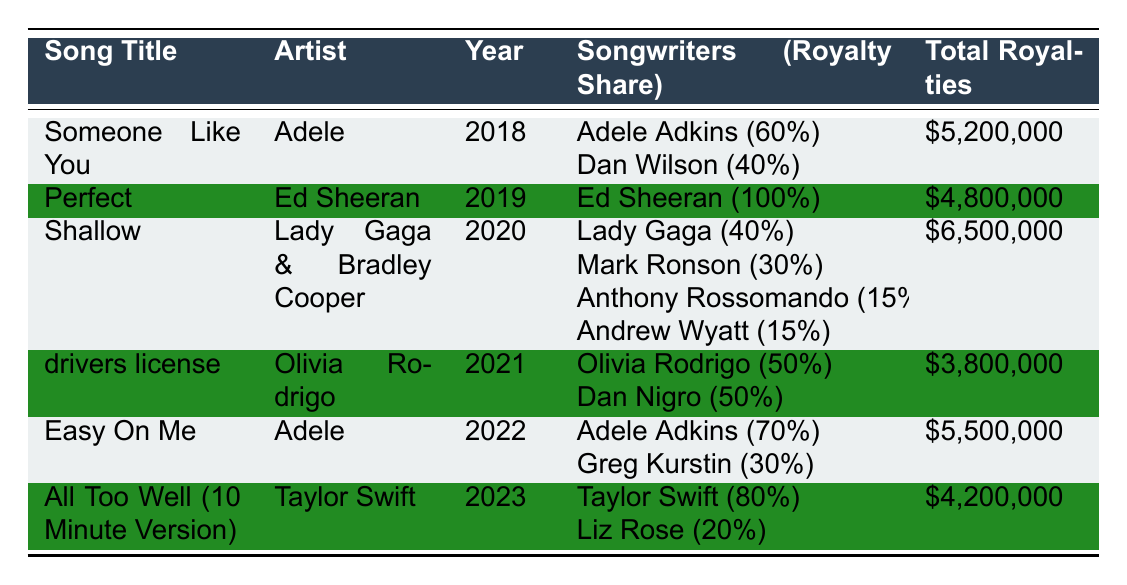What is the total royalty for the song "Shallow"? Referring to the table, the total royalties listed for "Shallow" is $6,500,000.
Answer: $6,500,000 Who are the songwriters for "drivers license"? Looking at the table, the songwriters for "drivers license" are Olivia Rodrigo and Dan Nigro.
Answer: Olivia Rodrigo and Dan Nigro Which artist had the highest total royalties for their song? Comparing the total royalties among all songs, "Shallow" by Lady Gaga & Bradley Cooper has the highest at $6,500,000.
Answer: Lady Gaga & Bradley Cooper How much did Adele earn from her songs combined? To find this, sum the total royalties of both "Someone Like You" ($5,200,000) and "Easy On Me" ($5,500,000): $5,200,000 + $5,500,000 = $10,700,000.
Answer: $10,700,000 Did "Perfect" generate more or less than $5,000,000 in royalties? The total royalties for "Perfect" is $4,800,000, which is less than $5,000,000.
Answer: Less What percentage of royalties did Taylor Swift receive from "All Too Well (10 Minute Version)"? In the table, it states that Taylor Swift received a royalty share of 80% for this song.
Answer: 80% Which year had the lowest total royalties for a chart-topping ballad? The table shows that "drivers license" had the lowest total royalties of $3,800,000 in 2021.
Answer: 2021 If we average the total royalties of all songs listed, what is that value? First, sum all total royalties: $5,200,000 + $4,800,000 + $6,500,000 + $3,800,000 + $5,500,000 + $4,200,000 = $30,000,000. Then divide by the number of songs (6): $30,000,000 / 6 = $5,000,000.
Answer: $5,000,000 How many songwriters contributed to "Shallow"? The table indicates that "Shallow" has four songwriters: Lady Gaga, Mark Ronson, Anthony Rossomando, and Andrew Wyatt.
Answer: Four Was there a song released in 2022 that generated more than $5,000,000? Yes, "Easy On Me" by Adele, released in 2022, generated $5,500,000 in royalties, which is more than $5,000,000.
Answer: Yes 